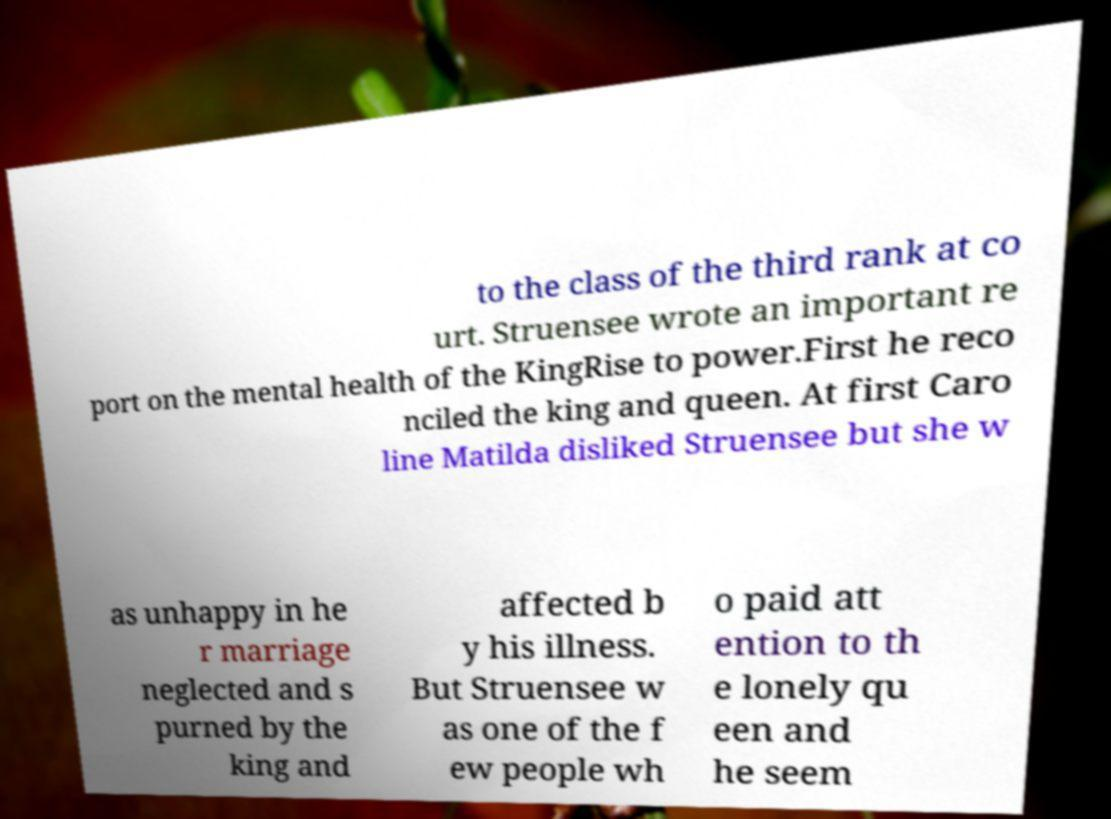There's text embedded in this image that I need extracted. Can you transcribe it verbatim? to the class of the third rank at co urt. Struensee wrote an important re port on the mental health of the KingRise to power.First he reco nciled the king and queen. At first Caro line Matilda disliked Struensee but she w as unhappy in he r marriage neglected and s purned by the king and affected b y his illness. But Struensee w as one of the f ew people wh o paid att ention to th e lonely qu een and he seem 